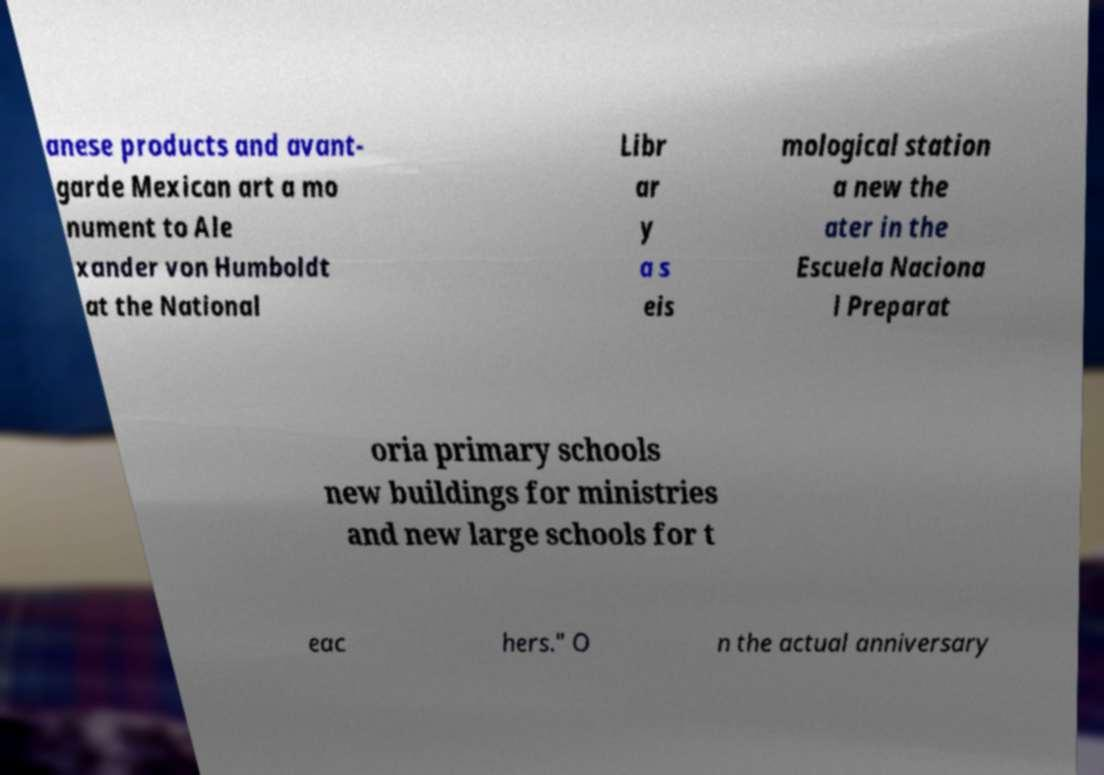Can you read and provide the text displayed in the image?This photo seems to have some interesting text. Can you extract and type it out for me? anese products and avant- garde Mexican art a mo nument to Ale xander von Humboldt at the National Libr ar y a s eis mological station a new the ater in the Escuela Naciona l Preparat oria primary schools new buildings for ministries and new large schools for t eac hers." O n the actual anniversary 